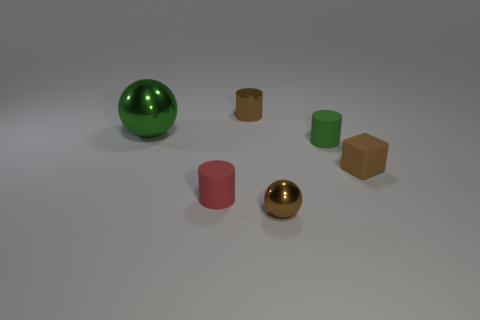There is a sphere that is the same color as the tiny metallic cylinder; what is its material?
Keep it short and to the point. Metal. How many tiny metal things are the same shape as the big green metal thing?
Give a very brief answer. 1. Is the color of the sphere left of the small metallic sphere the same as the matte cylinder behind the red cylinder?
Keep it short and to the point. Yes. What is the material of the red thing that is the same size as the block?
Provide a short and direct response. Rubber. Are there any purple matte spheres that have the same size as the brown rubber block?
Provide a short and direct response. No. Are there fewer tiny red matte things on the right side of the green metallic object than objects?
Make the answer very short. Yes. Are there fewer metallic cylinders in front of the brown cube than rubber cylinders to the left of the metallic cylinder?
Offer a terse response. Yes. What number of balls are either red things or brown metal objects?
Provide a succinct answer. 1. Is the material of the green thing that is on the right side of the tiny red matte object the same as the tiny cylinder on the left side of the brown cylinder?
Your response must be concise. Yes. What shape is the green thing that is the same size as the brown cylinder?
Keep it short and to the point. Cylinder. 